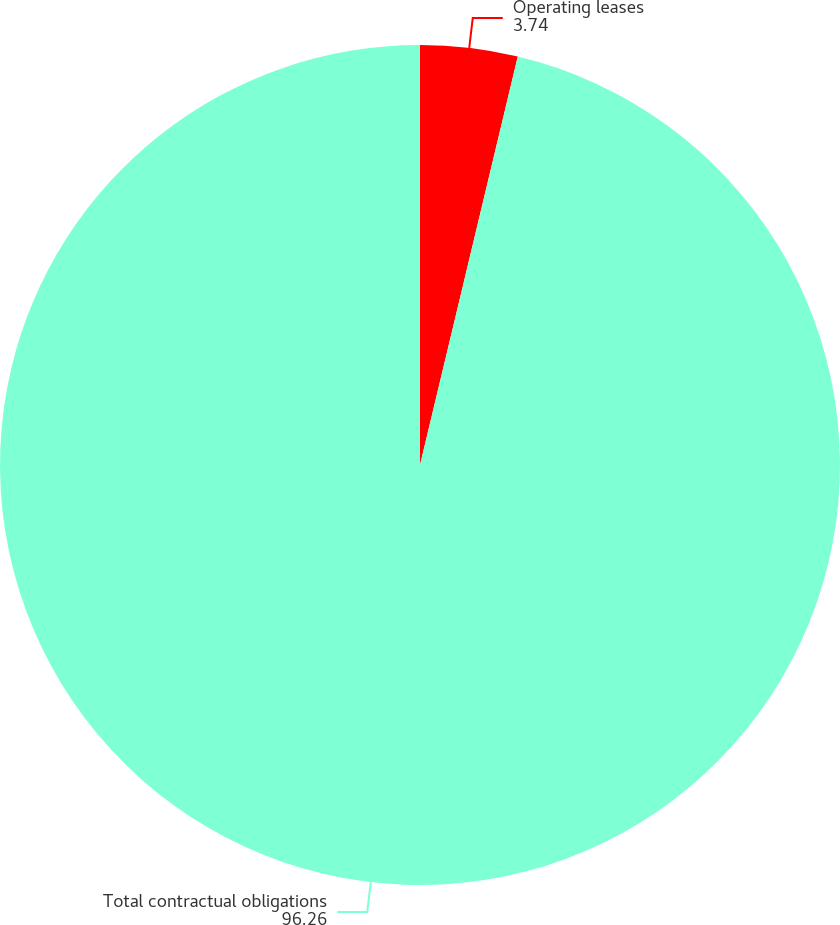Convert chart. <chart><loc_0><loc_0><loc_500><loc_500><pie_chart><fcel>Operating leases<fcel>Total contractual obligations<nl><fcel>3.74%<fcel>96.26%<nl></chart> 